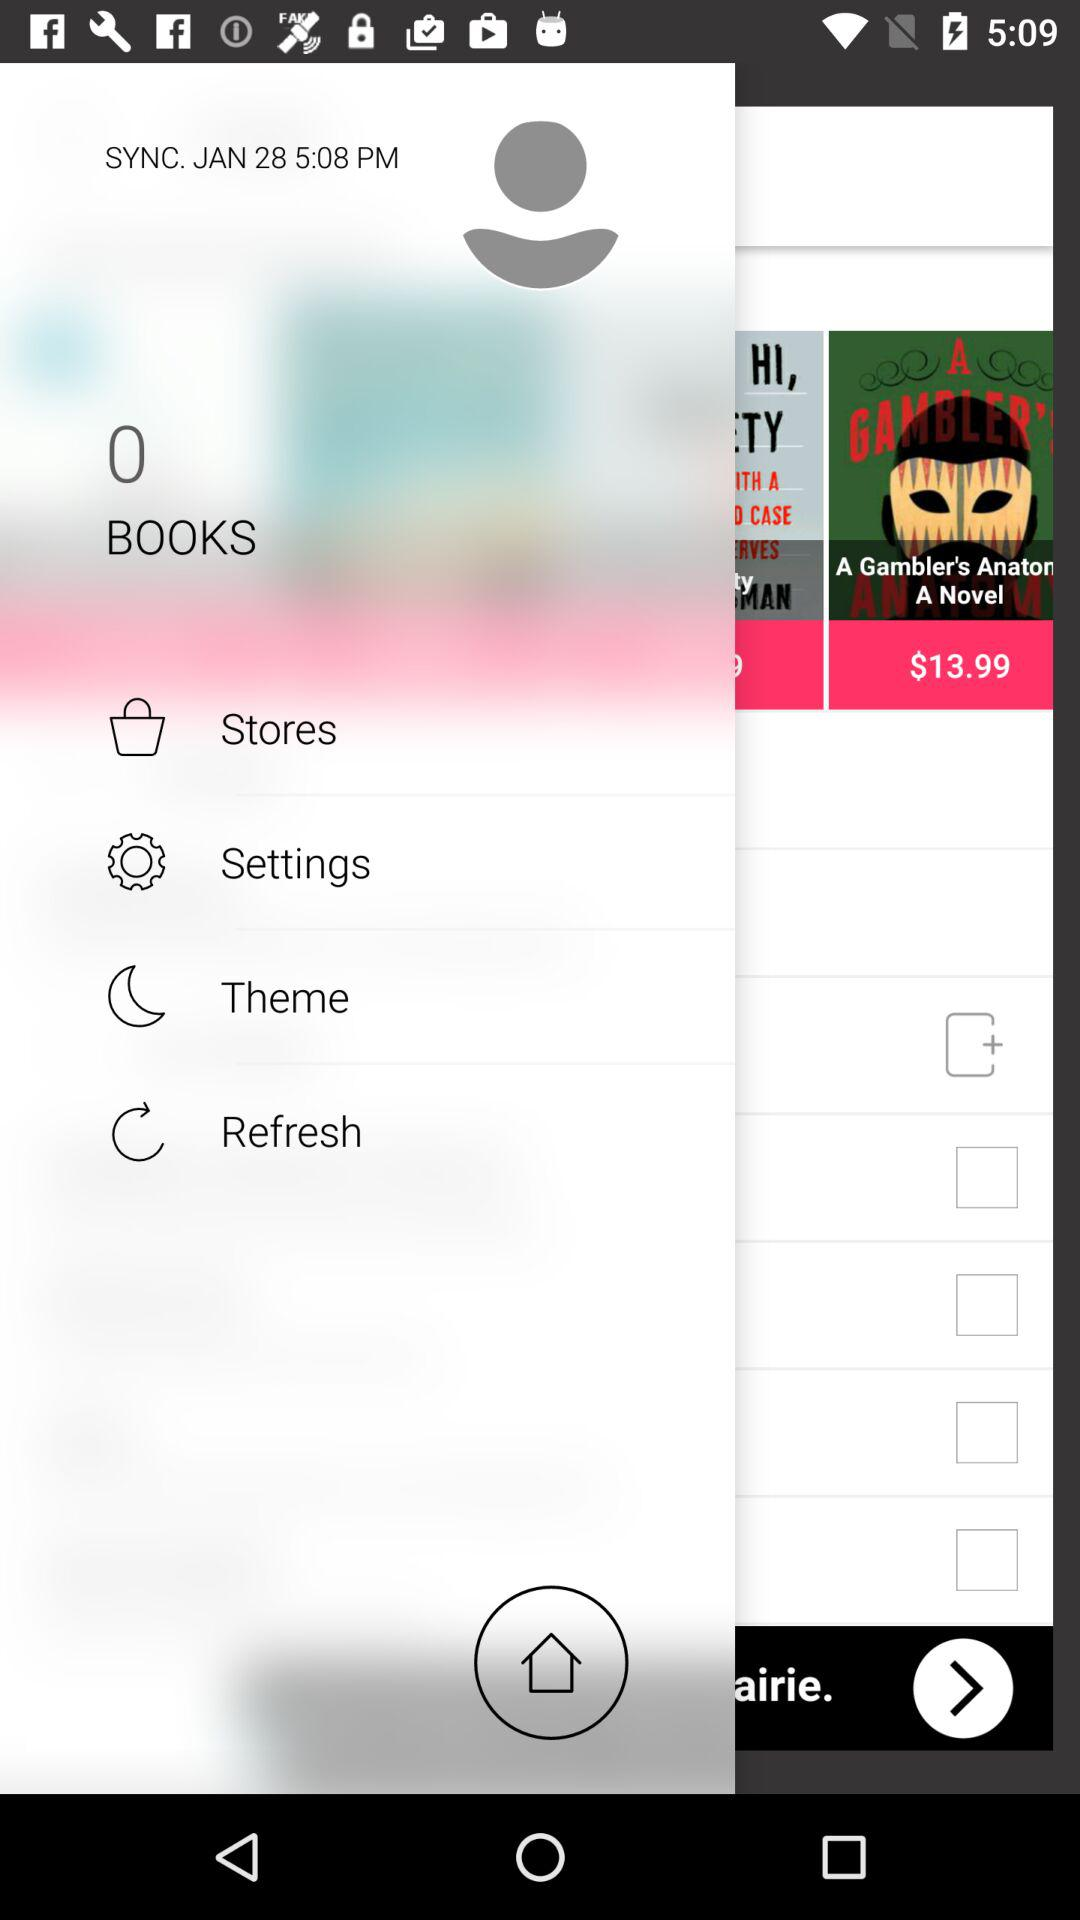What is the mentioned date and time? The mentioned date and time are January 28 and 5:08 PM, respectively. 